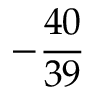<formula> <loc_0><loc_0><loc_500><loc_500>- { \frac { 4 0 } { 3 9 } }</formula> 